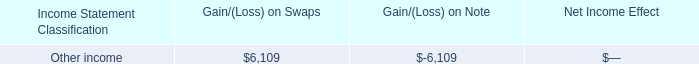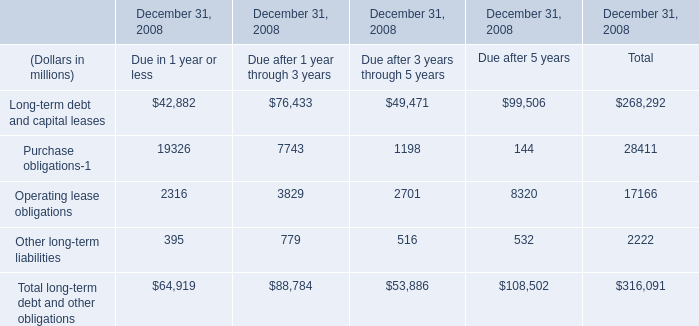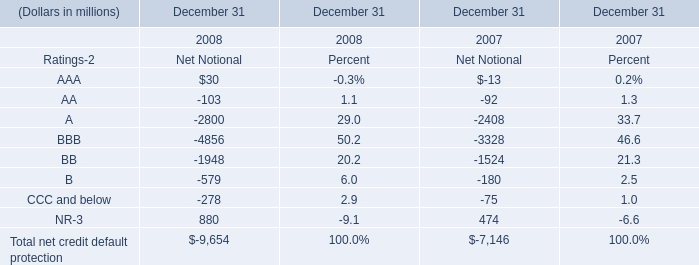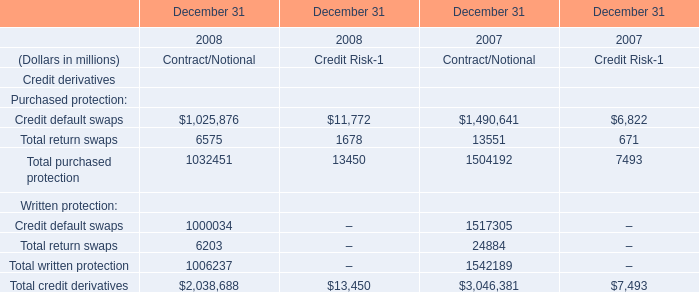What's the sum of Net Notional without those Net Notional smaller than 0, in 2008? (in million) 
Computations: (30 + 880)
Answer: 910.0. 